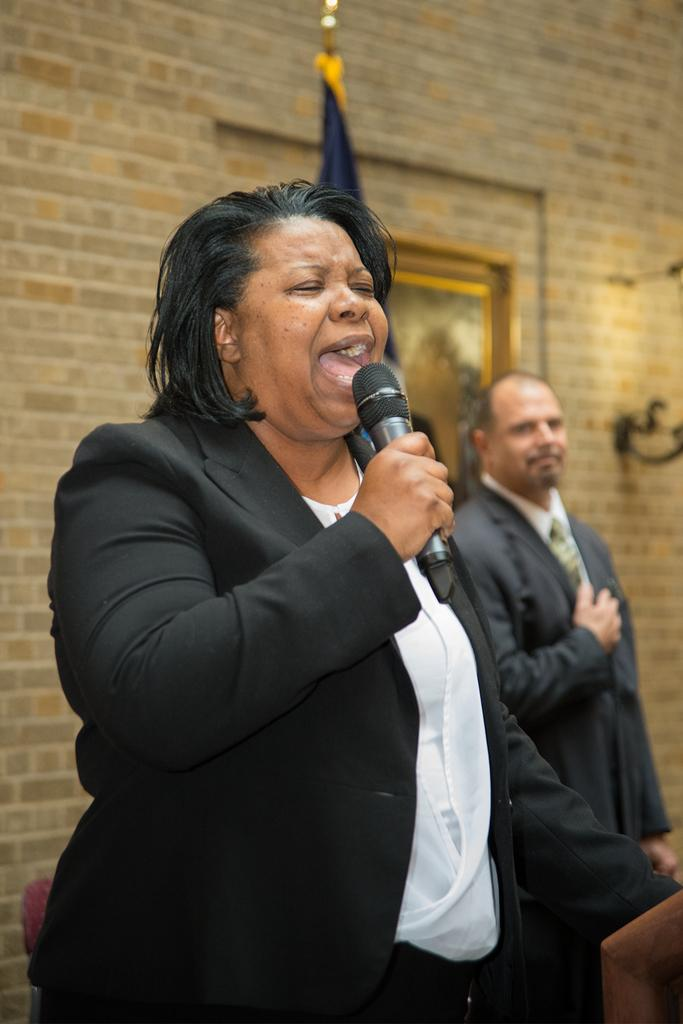What is the main subject of the image? There is a woman in the image. What is the woman doing in the image? The woman is standing and singing. What object is the woman holding in her hand? The woman is holding a mic in her hand. What can be seen in the background of the image? There is a man and a wall visible in the background of the image. What type of porter is assisting the woman in the image? There is no porter present in the image. How does the woman's singing compare to the man's singing in the background? The image does not provide any information about the man's singing, so a comparison cannot be made. 